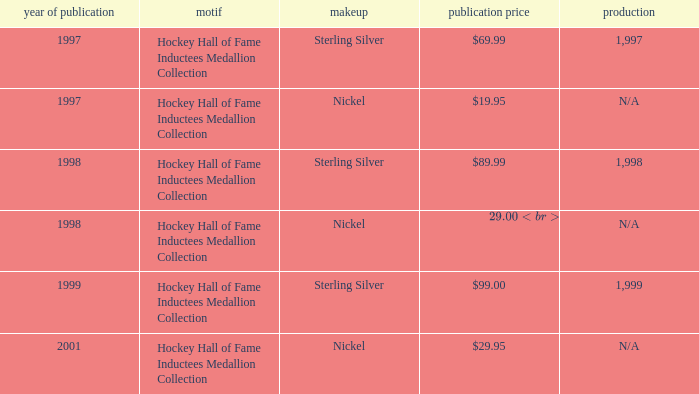Which composition has an issue price of $99.00? Sterling Silver. 